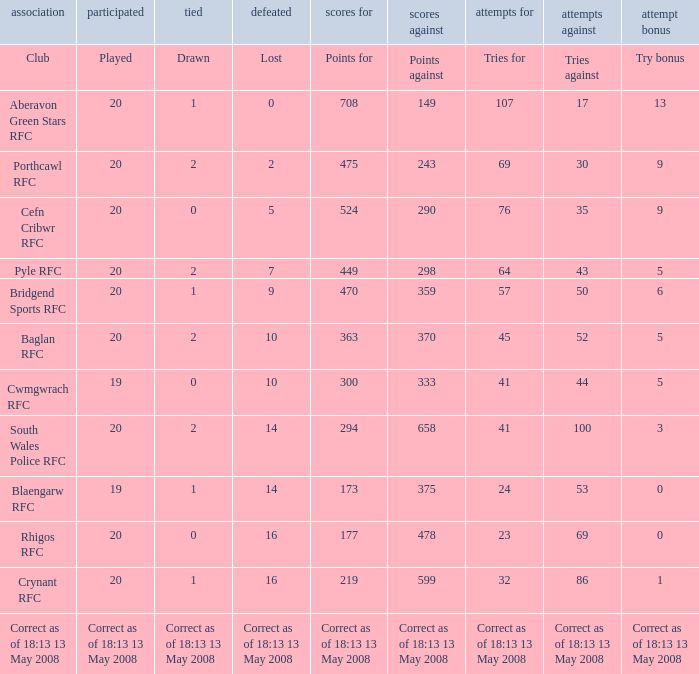What is the lost when the try bonus is 5, and points against is 298? 7.0. 